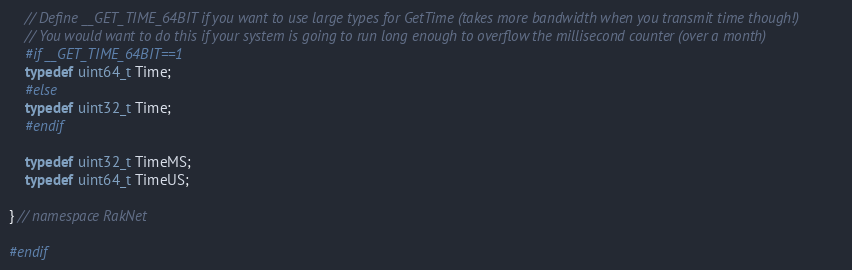Convert code to text. <code><loc_0><loc_0><loc_500><loc_500><_C_>
    // Define __GET_TIME_64BIT if you want to use large types for GetTime (takes more bandwidth when you transmit time though!)
    // You would want to do this if your system is going to run long enough to overflow the millisecond counter (over a month)
    #if __GET_TIME_64BIT==1
    typedef uint64_t Time;
    #else
    typedef uint32_t Time;
    #endif

    typedef uint32_t TimeMS;
    typedef uint64_t TimeUS;

} // namespace RakNet

#endif
</code> 